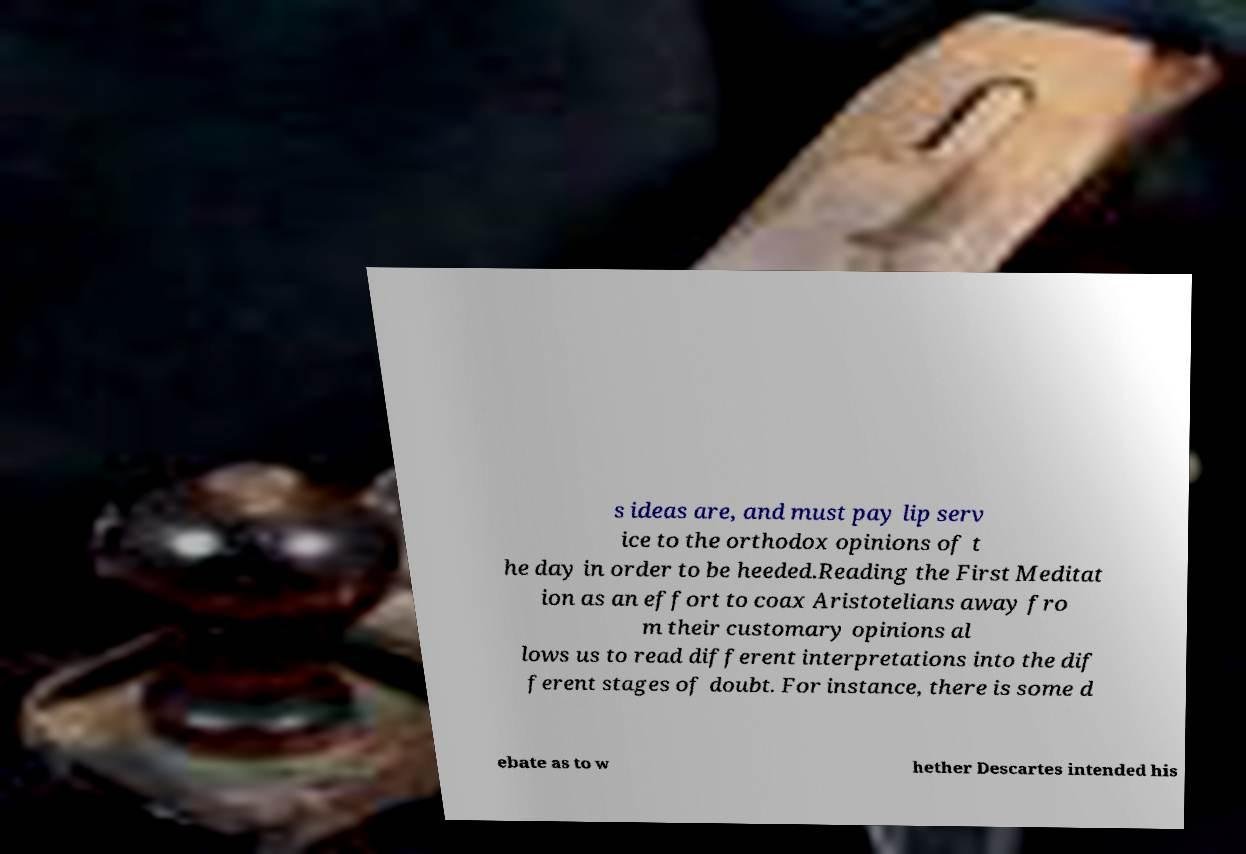I need the written content from this picture converted into text. Can you do that? s ideas are, and must pay lip serv ice to the orthodox opinions of t he day in order to be heeded.Reading the First Meditat ion as an effort to coax Aristotelians away fro m their customary opinions al lows us to read different interpretations into the dif ferent stages of doubt. For instance, there is some d ebate as to w hether Descartes intended his 